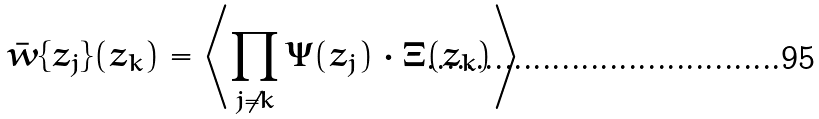Convert formula to latex. <formula><loc_0><loc_0><loc_500><loc_500>\bar { w } \{ z _ { j } \} ( z _ { k } ) = \left \langle \prod _ { j \neq k } \Psi ( z _ { j } ) \cdot \Xi ( z _ { k } ) \right \rangle</formula> 